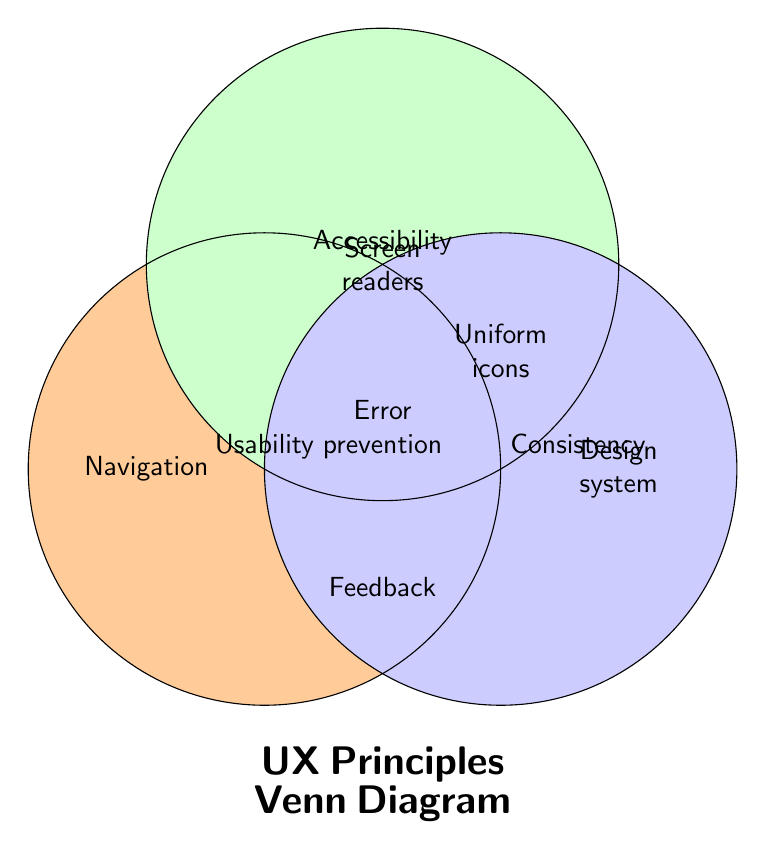What is the title of the Venn Diagram? The title is written at the bottom middle of the figure and it says "UX Principles Venn Diagram."
Answer: UX Principles Venn Diagram Which section of the Venn Diagram mentions "Navigation"? The label "Navigation" is positioned within the circle labeled Usability on the left side.
Answer: Usability Identify the principle associated with "Screen readers." The term "Screen readers" is located within the circle labeled Accessibility, at the top right.
Answer: Accessibility Where is the principle of "Design system" located? "Design system" is located within the third circle labeled Consistency on the right side.
Answer: Consistency Which UX principle encompasses "Error prevention" and "Feedback"? Both "Error prevention" and "Feedback" are found within the section where the Usability circle overlaps with the other circles. This indicates the principle is Usability.
Answer: Usability Find the principle that "Uniform icons" are associated with. "Uniform icons" is located within the section where the Consistency circle overlaps, specifically on the right side.
Answer: Consistency How many principles overlap to share "Uniform icons"? "Uniform icons" is located at the intersection of the Consistency circle overlapping with the other circles, so it involves only one principle.
Answer: One Compare the overlaps: Does "Screen readers" overlap with more or fewer principles than "Navigation"? "Screen readers" is within the Accessibility circle and does not overlap with other principles, while "Navigation" is within the Usability circle and does not overlap either. Both terms are in single principles and do not overlap with others.
Answer: Equal Which elements are shared by Usability and Accessibility? The Venn Diagram does not explicitly label any shared elements between Usability and Accessibility circles.
Answer: None 